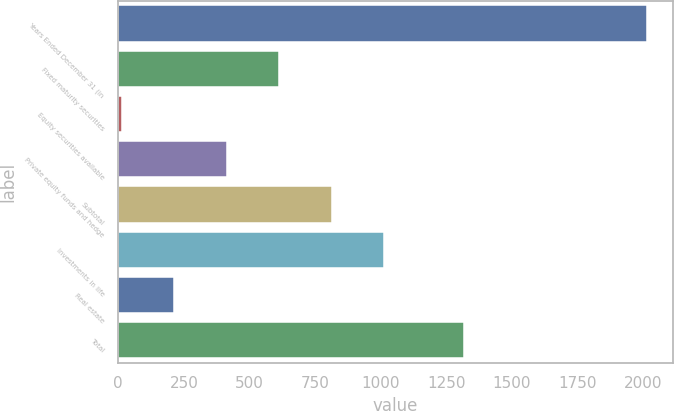<chart> <loc_0><loc_0><loc_500><loc_500><bar_chart><fcel>Years Ended December 31 (in<fcel>Fixed maturity securities<fcel>Equity securities available<fcel>Private equity funds and hedge<fcel>Subtotal<fcel>Investments in life<fcel>Real estate<fcel>Total<nl><fcel>2013<fcel>613.7<fcel>14<fcel>413.8<fcel>813.6<fcel>1013.5<fcel>213.9<fcel>1317<nl></chart> 